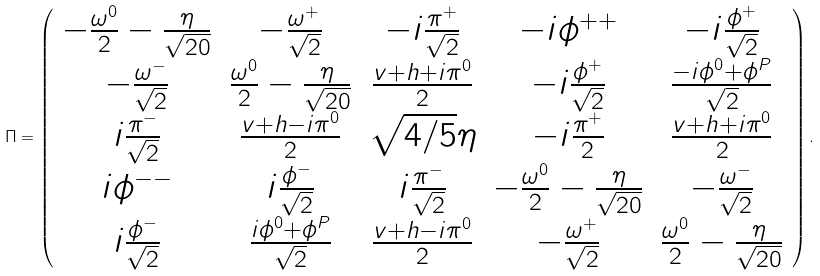Convert formula to latex. <formula><loc_0><loc_0><loc_500><loc_500>\Pi = \left ( \begin{array} { c c c c c } - \frac { \omega ^ { 0 } } { 2 } - \frac { \eta } { \sqrt { 2 0 } } & - \frac { \omega ^ { + } } { \sqrt { 2 } } & - i \frac { \pi ^ { + } } { \sqrt { 2 } } & - i \phi ^ { + + } & - i \frac { \phi ^ { + } } { \sqrt { 2 } } \\ - \frac { \omega ^ { - } } { \sqrt { 2 } } & \frac { \omega ^ { 0 } } { 2 } - \frac { \eta } { \sqrt { 2 0 } } & \frac { v + h + i \pi ^ { 0 } } { 2 } & - i \frac { \phi ^ { + } } { \sqrt { 2 } } & \frac { - i \phi ^ { 0 } + \phi ^ { P } } { \sqrt { 2 } } \\ i \frac { \pi ^ { - } } { \sqrt { 2 } } & \frac { v + h - i \pi ^ { 0 } } { 2 } & \sqrt { 4 / 5 } \eta & - i \frac { \pi ^ { + } } { 2 } & \frac { v + h + i \pi ^ { 0 } } { 2 } \\ i \phi ^ { - - } & i \frac { \phi ^ { - } } { \sqrt { 2 } } & i \frac { \pi ^ { - } } { \sqrt { 2 } } & - \frac { \omega ^ { 0 } } { 2 } - \frac { \eta } { \sqrt { 2 0 } } & - \frac { \omega ^ { - } } { \sqrt { 2 } } \\ i \frac { \phi ^ { - } } { \sqrt { 2 } } & \frac { i \phi ^ { 0 } + \phi ^ { P } } { \sqrt { 2 } } & \frac { v + h - i \pi ^ { 0 } } { 2 } & - \frac { \omega ^ { + } } { \sqrt { 2 } } & \frac { \omega ^ { 0 } } { 2 } - \frac { \eta } { \sqrt { 2 0 } } \end{array} \right ) .</formula> 